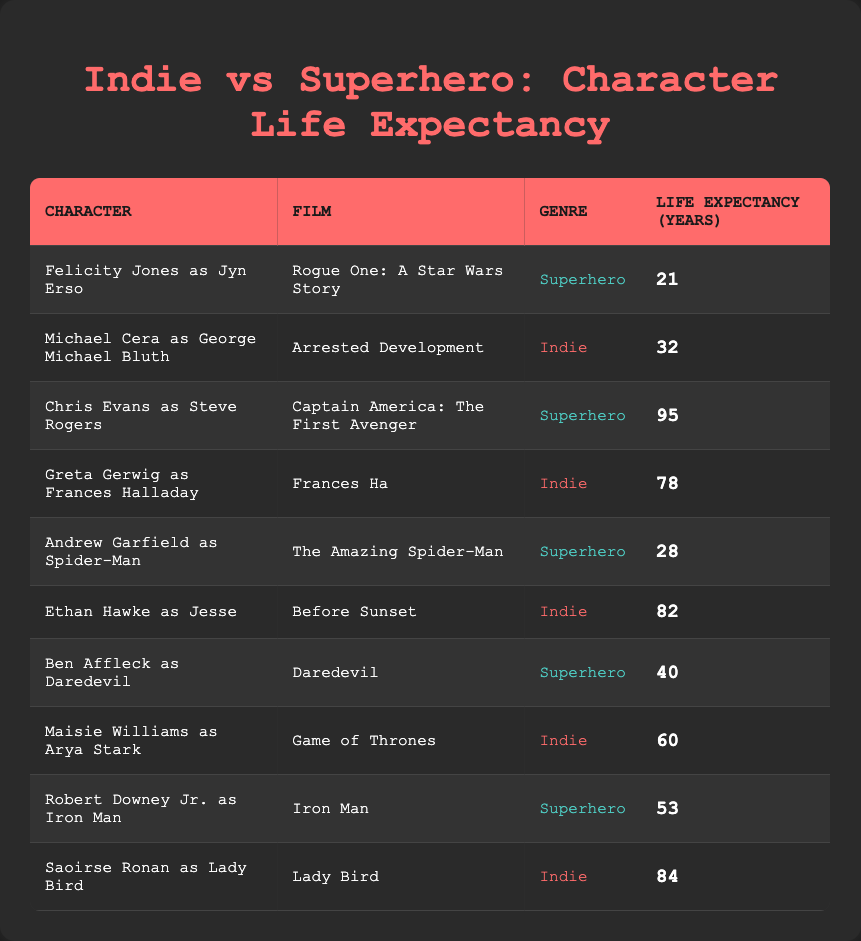What is the life expectancy of Felicity Jones as Jyn Erso? According to the table, Felicity Jones as Jyn Erso has a life expectancy of 21 years.
Answer: 21 What is the highest life expectancy in the superhero genre? The table shows that Chris Evans as Steve Rogers has the highest life expectancy of 95 years among the superhero characters.
Answer: 95 What is the average life expectancy of characters in indie films? To find the average for indie films, we add the life expectancies of characters: 32 (George Michael Bluth) + 78 (Frances Halladay) + 82 (Jesse) + 60 (Arya Stark) + 84 (Lady Bird) = 336. There are 5 characters, so the average is 336/5 = 67.2.
Answer: 67.2 Did any indie film character have a life expectancy lower than 40 years? By checking the table, I see that Michael Cera as George Michael Bluth has a life expectancy of 32 years, which is indeed lower than 40.
Answer: Yes Which genre has a character with the lowest life expectancy, and what is that expectancy? Looking at the table, Felicity Jones as Jyn Erso has the lowest life expectancy at 21 years, and she is in the superhero genre.
Answer: Superhero, 21 years What are the life expectancies of the superhero characters that are above 40 years? From the table, there are two superhero characters with life expectancies above 40 years: Chris Evans as Steve Rogers (95 years) and Robert Downey Jr. as Iron Man (53 years).
Answer: 95, 53 Which indie film character has the closest life expectancy to that of Andrew Garfield as Spider-Man? Andrew Garfield as Spider-Man has a life expectancy of 28 years. The indie film character with the closest life expectancy is Michael Cera as George Michael Bluth, who has a life expectancy of 32 years.
Answer: Michael Cera, 32 years Calculate the difference in life expectancy between the oldest indie character and the youngest superhero character. The oldest indie character is Chris Evans as Steve Rogers (95 years), and the youngest superhero character is Felicity Jones as Jyn Erso (21 years). The difference is 95 - 21 = 74 years.
Answer: 74 Are there more superhero characters with a life expectancy below the average life expectancy of indie film characters? The average life expectancy of indie film characters (67.2) is compared to the superhero characters. Only two superhero characters, Felicity Jones as Jyn Erso (21 years) and Andrew Garfield as Spider-Man (28 years), fall below this average, which means there are more than one.
Answer: Yes 